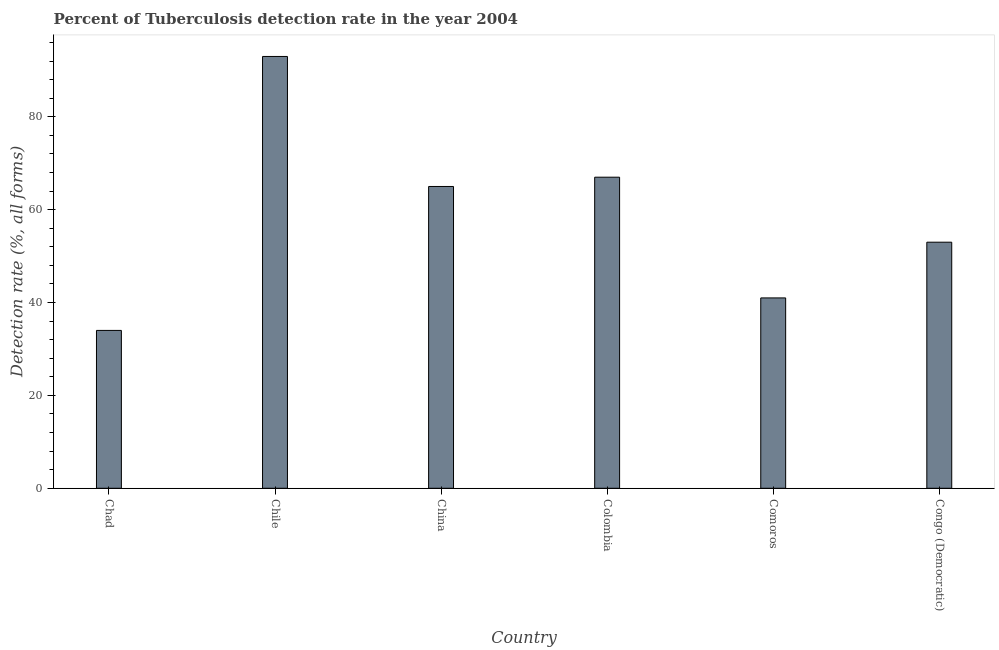Does the graph contain any zero values?
Make the answer very short. No. What is the title of the graph?
Ensure brevity in your answer.  Percent of Tuberculosis detection rate in the year 2004. What is the label or title of the Y-axis?
Ensure brevity in your answer.  Detection rate (%, all forms). What is the detection rate of tuberculosis in China?
Ensure brevity in your answer.  65. Across all countries, what is the maximum detection rate of tuberculosis?
Provide a short and direct response. 93. Across all countries, what is the minimum detection rate of tuberculosis?
Your response must be concise. 34. In which country was the detection rate of tuberculosis minimum?
Your answer should be compact. Chad. What is the sum of the detection rate of tuberculosis?
Your answer should be very brief. 353. What is the difference between the detection rate of tuberculosis in China and Congo (Democratic)?
Keep it short and to the point. 12. What is the average detection rate of tuberculosis per country?
Your response must be concise. 58. What is the ratio of the detection rate of tuberculosis in Chile to that in Comoros?
Offer a very short reply. 2.27. What is the difference between the highest and the second highest detection rate of tuberculosis?
Offer a terse response. 26. Is the sum of the detection rate of tuberculosis in Chile and Colombia greater than the maximum detection rate of tuberculosis across all countries?
Offer a very short reply. Yes. In how many countries, is the detection rate of tuberculosis greater than the average detection rate of tuberculosis taken over all countries?
Offer a terse response. 3. What is the Detection rate (%, all forms) of Chad?
Offer a very short reply. 34. What is the Detection rate (%, all forms) in Chile?
Keep it short and to the point. 93. What is the Detection rate (%, all forms) in Comoros?
Provide a succinct answer. 41. What is the Detection rate (%, all forms) in Congo (Democratic)?
Ensure brevity in your answer.  53. What is the difference between the Detection rate (%, all forms) in Chad and Chile?
Ensure brevity in your answer.  -59. What is the difference between the Detection rate (%, all forms) in Chad and China?
Offer a very short reply. -31. What is the difference between the Detection rate (%, all forms) in Chad and Colombia?
Offer a terse response. -33. What is the difference between the Detection rate (%, all forms) in Chad and Comoros?
Ensure brevity in your answer.  -7. What is the difference between the Detection rate (%, all forms) in Chad and Congo (Democratic)?
Keep it short and to the point. -19. What is the difference between the Detection rate (%, all forms) in Chile and China?
Your answer should be compact. 28. What is the difference between the Detection rate (%, all forms) in Chile and Colombia?
Give a very brief answer. 26. What is the difference between the Detection rate (%, all forms) in China and Comoros?
Your answer should be very brief. 24. What is the difference between the Detection rate (%, all forms) in China and Congo (Democratic)?
Keep it short and to the point. 12. What is the difference between the Detection rate (%, all forms) in Colombia and Comoros?
Your response must be concise. 26. What is the ratio of the Detection rate (%, all forms) in Chad to that in Chile?
Make the answer very short. 0.37. What is the ratio of the Detection rate (%, all forms) in Chad to that in China?
Your answer should be very brief. 0.52. What is the ratio of the Detection rate (%, all forms) in Chad to that in Colombia?
Your response must be concise. 0.51. What is the ratio of the Detection rate (%, all forms) in Chad to that in Comoros?
Offer a terse response. 0.83. What is the ratio of the Detection rate (%, all forms) in Chad to that in Congo (Democratic)?
Offer a very short reply. 0.64. What is the ratio of the Detection rate (%, all forms) in Chile to that in China?
Provide a succinct answer. 1.43. What is the ratio of the Detection rate (%, all forms) in Chile to that in Colombia?
Give a very brief answer. 1.39. What is the ratio of the Detection rate (%, all forms) in Chile to that in Comoros?
Offer a terse response. 2.27. What is the ratio of the Detection rate (%, all forms) in Chile to that in Congo (Democratic)?
Make the answer very short. 1.75. What is the ratio of the Detection rate (%, all forms) in China to that in Comoros?
Your answer should be compact. 1.58. What is the ratio of the Detection rate (%, all forms) in China to that in Congo (Democratic)?
Provide a succinct answer. 1.23. What is the ratio of the Detection rate (%, all forms) in Colombia to that in Comoros?
Offer a very short reply. 1.63. What is the ratio of the Detection rate (%, all forms) in Colombia to that in Congo (Democratic)?
Your response must be concise. 1.26. What is the ratio of the Detection rate (%, all forms) in Comoros to that in Congo (Democratic)?
Your response must be concise. 0.77. 